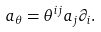<formula> <loc_0><loc_0><loc_500><loc_500>a _ { \theta } = \theta ^ { i j } a _ { j } \partial _ { i } .</formula> 